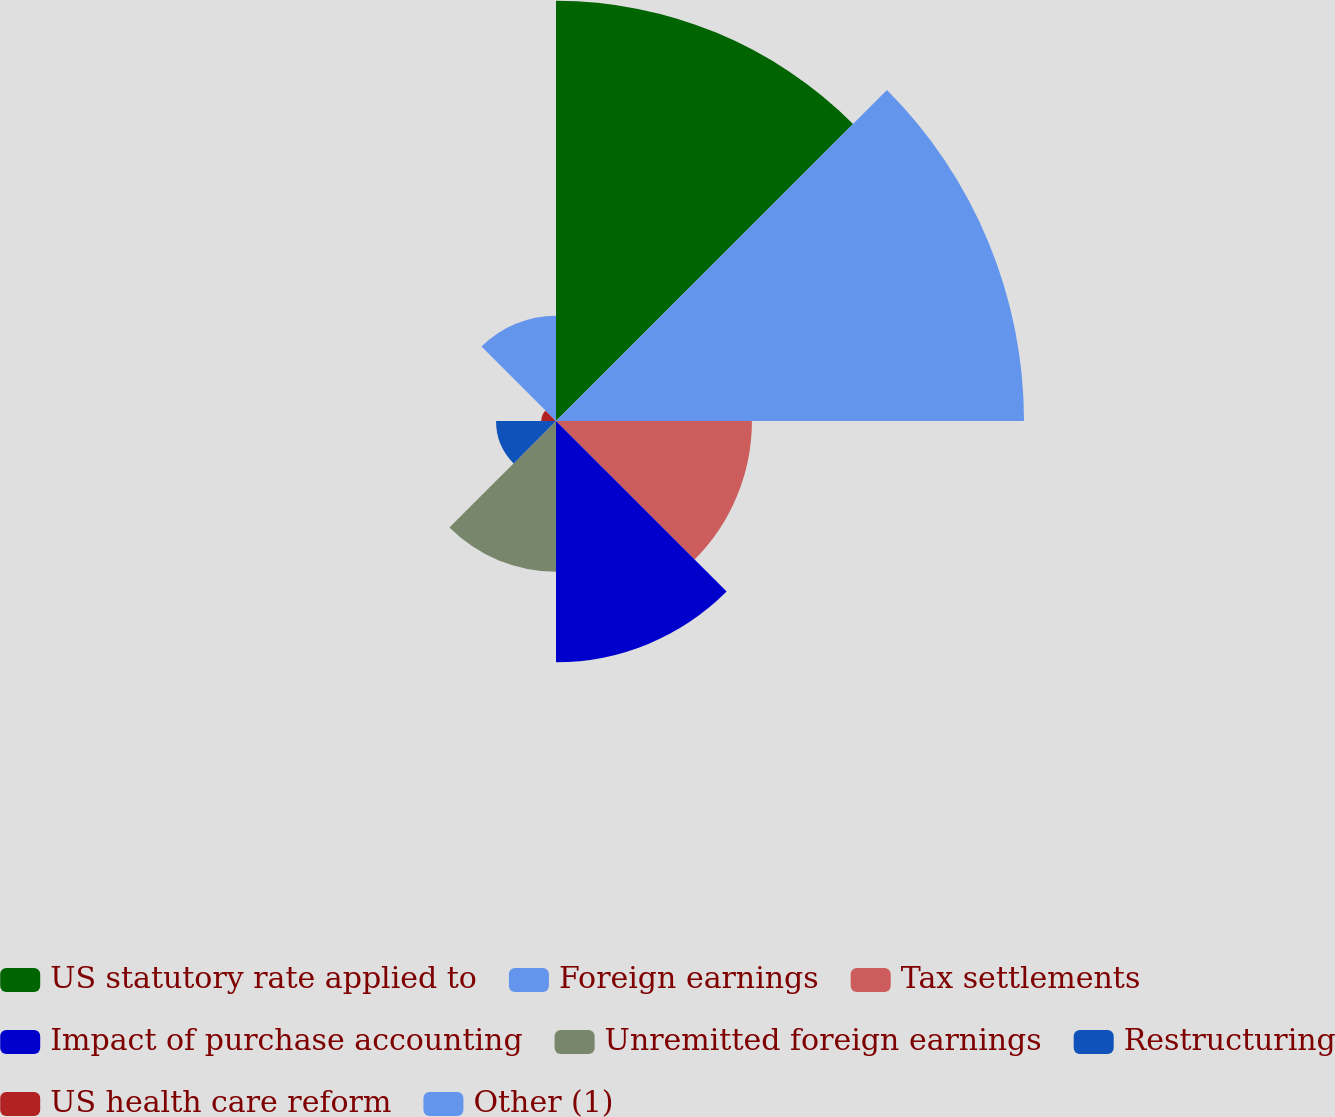Convert chart. <chart><loc_0><loc_0><loc_500><loc_500><pie_chart><fcel>US statutory rate applied to<fcel>Foreign earnings<fcel>Tax settlements<fcel>Impact of purchase accounting<fcel>Unremitted foreign earnings<fcel>Restructuring<fcel>US health care reform<fcel>Other (1)<nl><fcel>25.37%<fcel>28.26%<fcel>11.83%<fcel>14.57%<fcel>9.1%<fcel>3.62%<fcel>0.89%<fcel>6.36%<nl></chart> 